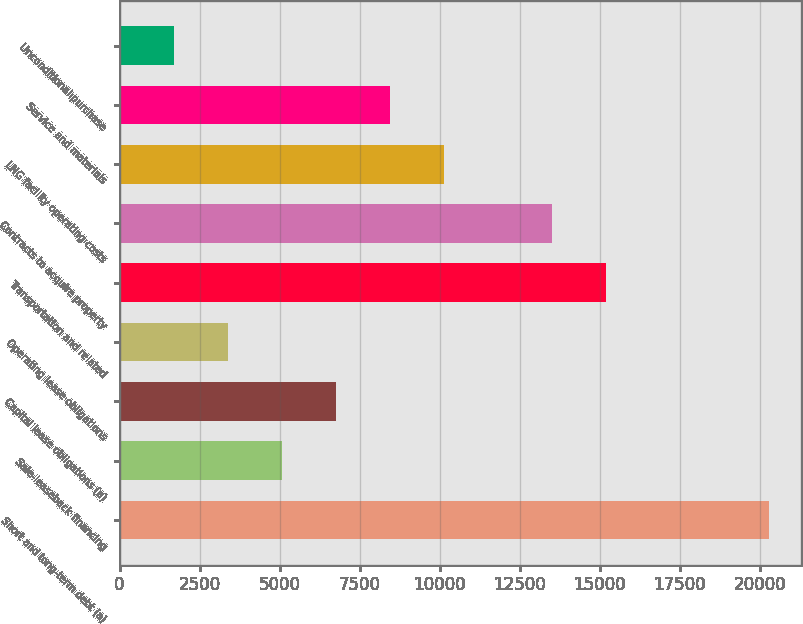Convert chart. <chart><loc_0><loc_0><loc_500><loc_500><bar_chart><fcel>Short and long-term debt (a)<fcel>Sale-leaseback financing<fcel>Capital lease obligations (a)<fcel>Operating lease obligations<fcel>Transportation and related<fcel>Contracts to acquire property<fcel>LNG facility operating costs<fcel>Service and materials<fcel>Unconditional purchase<nl><fcel>20273.2<fcel>5084.8<fcel>6772.4<fcel>3397.2<fcel>15210.4<fcel>13522.8<fcel>10147.6<fcel>8460<fcel>1709.6<nl></chart> 